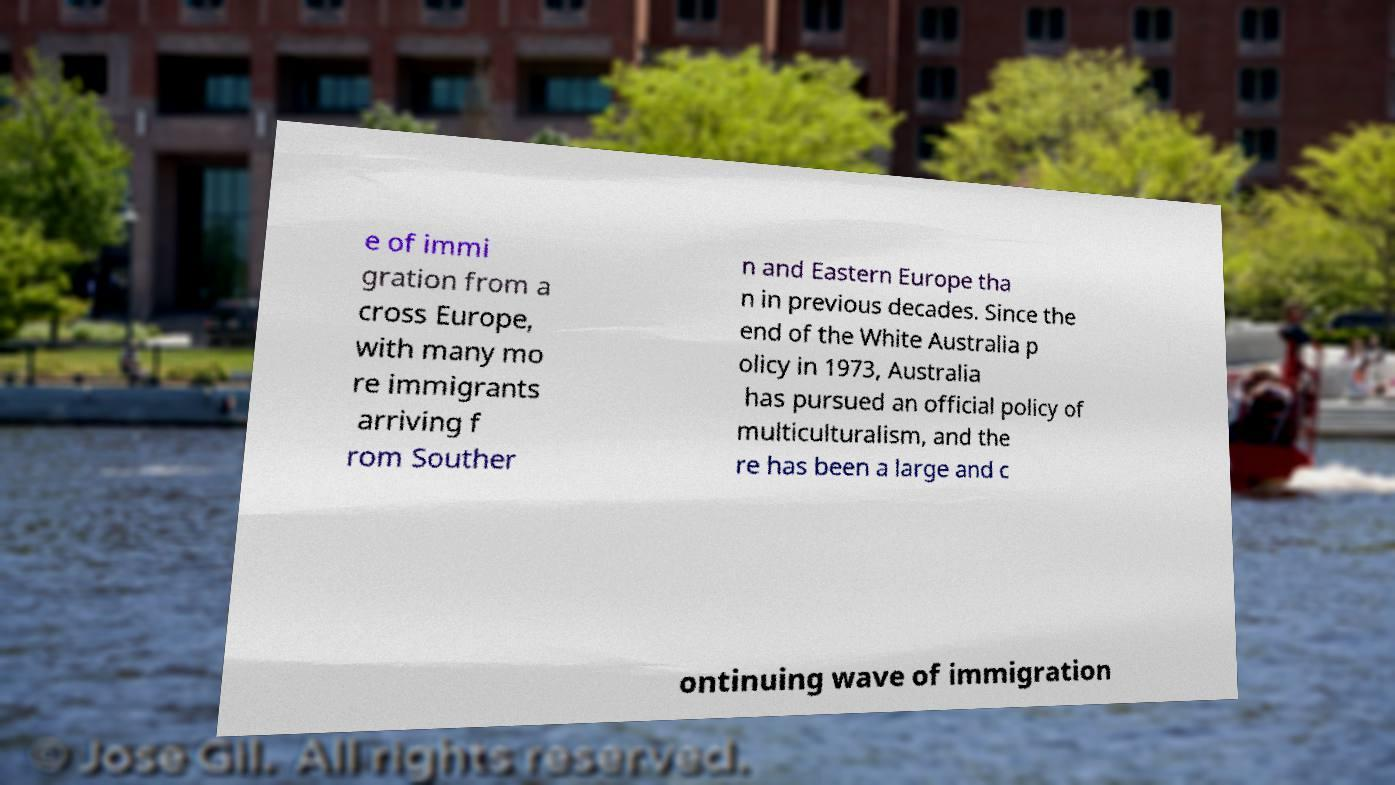Please read and relay the text visible in this image. What does it say? e of immi gration from a cross Europe, with many mo re immigrants arriving f rom Souther n and Eastern Europe tha n in previous decades. Since the end of the White Australia p olicy in 1973, Australia has pursued an official policy of multiculturalism, and the re has been a large and c ontinuing wave of immigration 